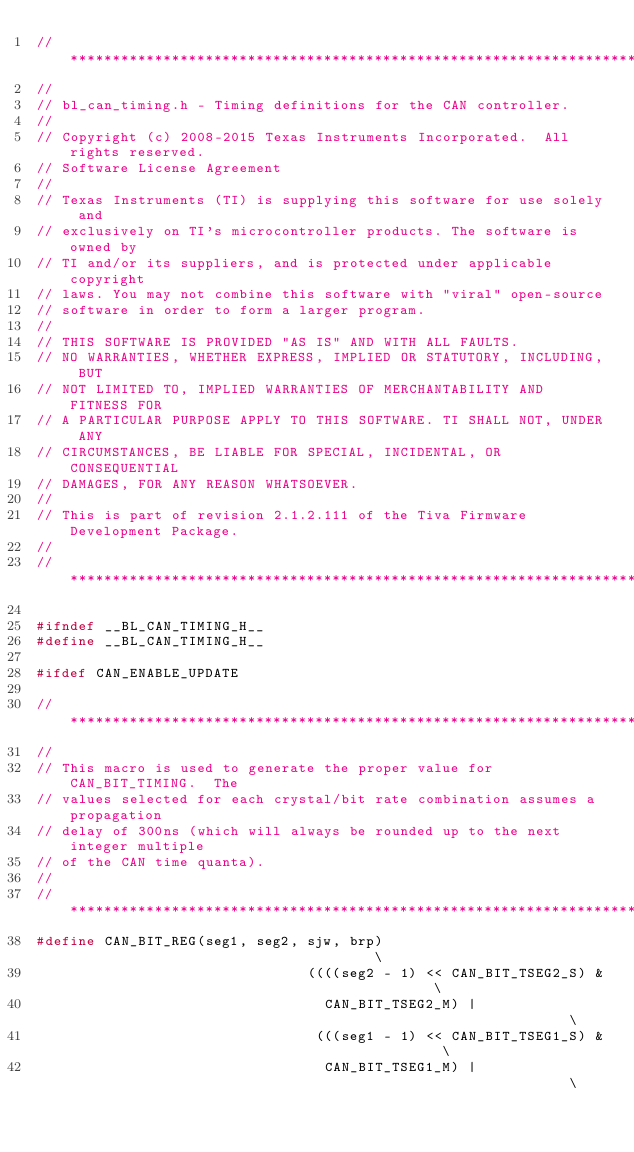<code> <loc_0><loc_0><loc_500><loc_500><_C_>//*****************************************************************************
//
// bl_can_timing.h - Timing definitions for the CAN controller.
//
// Copyright (c) 2008-2015 Texas Instruments Incorporated.  All rights reserved.
// Software License Agreement
// 
// Texas Instruments (TI) is supplying this software for use solely and
// exclusively on TI's microcontroller products. The software is owned by
// TI and/or its suppliers, and is protected under applicable copyright
// laws. You may not combine this software with "viral" open-source
// software in order to form a larger program.
// 
// THIS SOFTWARE IS PROVIDED "AS IS" AND WITH ALL FAULTS.
// NO WARRANTIES, WHETHER EXPRESS, IMPLIED OR STATUTORY, INCLUDING, BUT
// NOT LIMITED TO, IMPLIED WARRANTIES OF MERCHANTABILITY AND FITNESS FOR
// A PARTICULAR PURPOSE APPLY TO THIS SOFTWARE. TI SHALL NOT, UNDER ANY
// CIRCUMSTANCES, BE LIABLE FOR SPECIAL, INCIDENTAL, OR CONSEQUENTIAL
// DAMAGES, FOR ANY REASON WHATSOEVER.
// 
// This is part of revision 2.1.2.111 of the Tiva Firmware Development Package.
//
//*****************************************************************************

#ifndef __BL_CAN_TIMING_H__
#define __BL_CAN_TIMING_H__

#ifdef CAN_ENABLE_UPDATE

//*****************************************************************************
//
// This macro is used to generate the proper value for CAN_BIT_TIMING.  The
// values selected for each crystal/bit rate combination assumes a propagation
// delay of 300ns (which will always be rounded up to the next integer multiple
// of the CAN time quanta).
//
//*****************************************************************************
#define CAN_BIT_REG(seg1, seg2, sjw, brp)                                     \
                                ((((seg2 - 1) << CAN_BIT_TSEG2_S) &           \
                                  CAN_BIT_TSEG2_M) |                          \
                                 (((seg1 - 1) << CAN_BIT_TSEG1_S) &           \
                                  CAN_BIT_TSEG1_M) |                          \</code> 